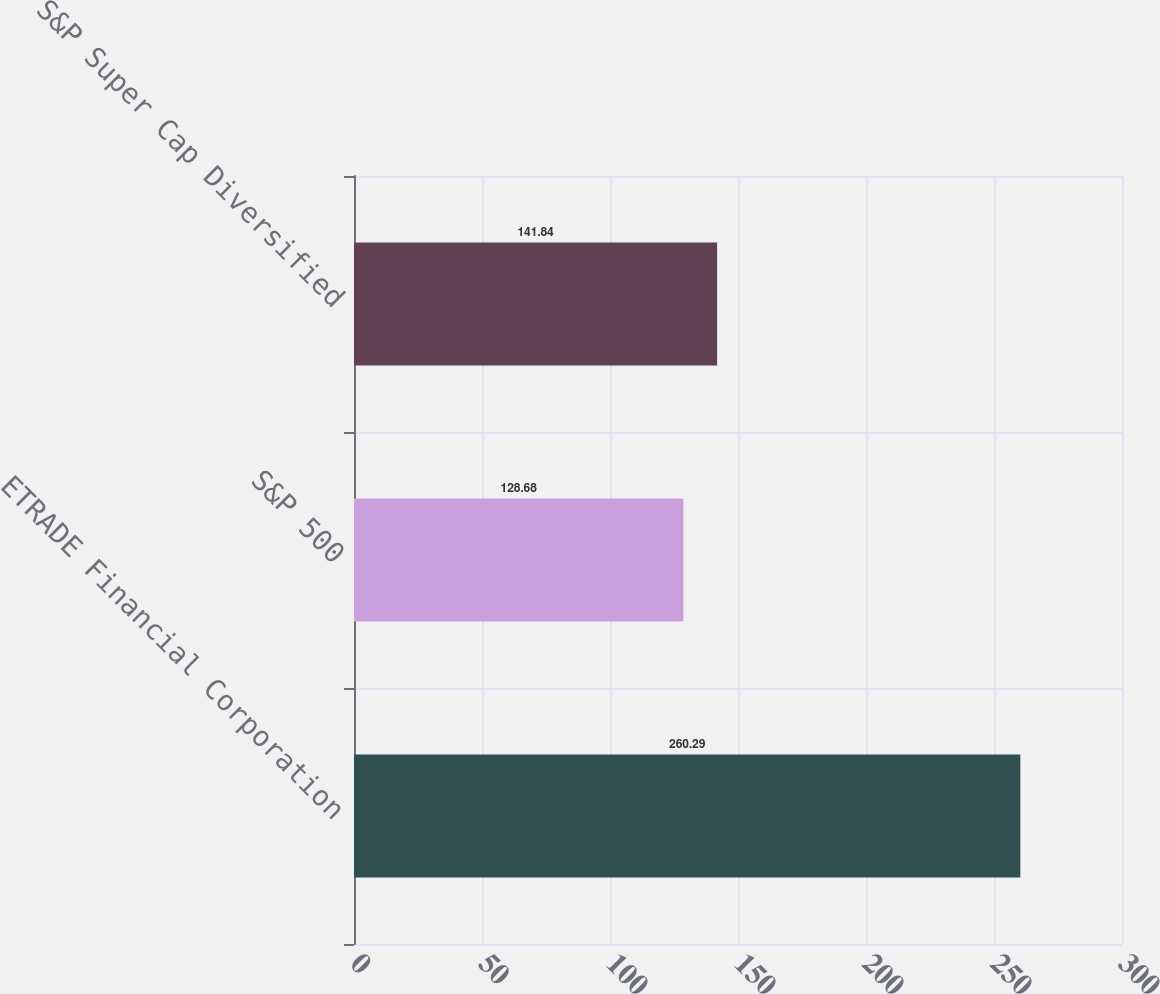Convert chart. <chart><loc_0><loc_0><loc_500><loc_500><bar_chart><fcel>ETRADE Financial Corporation<fcel>S&P 500<fcel>S&P Super Cap Diversified<nl><fcel>260.29<fcel>128.68<fcel>141.84<nl></chart> 